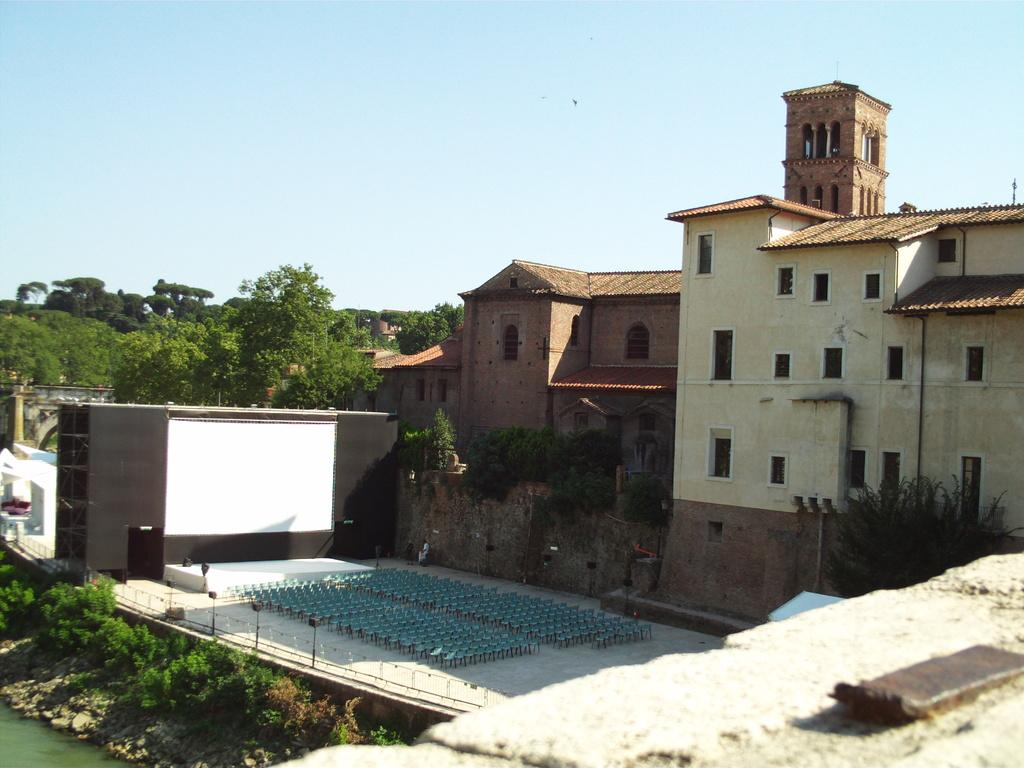What can be seen in the bottom left of the image? There is water in the bottom left of the image. What type of vegetation is present in the image? There are plants and trees in the image. What type of man-made structures can be seen in the image? There are buildings in the image. What else can be seen in the image besides the water, plants, trees, and buildings? There are other objects in the image. What is visible at the top of the image? The sky is visible at the top of the image. What type of stage is visible in the image? There is no stage present in the image. How does the control panel operate in the image? There is no control panel present in the image. 